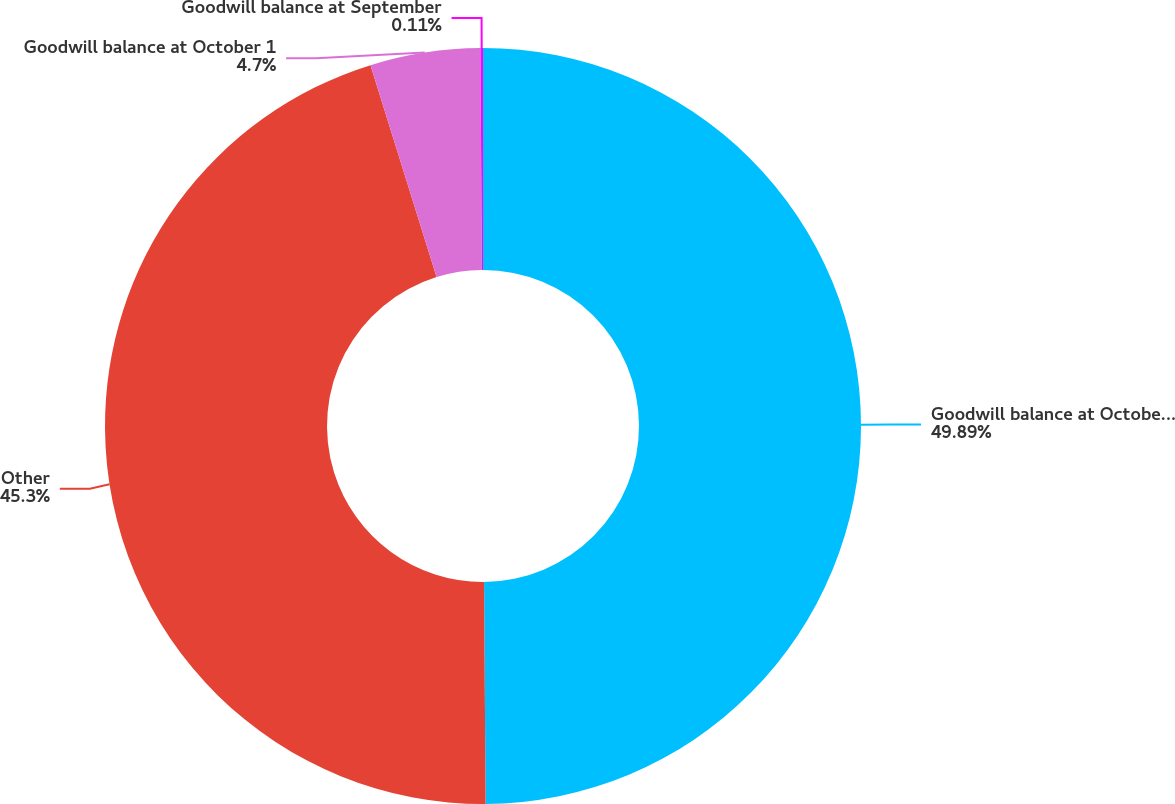<chart> <loc_0><loc_0><loc_500><loc_500><pie_chart><fcel>Goodwill balance at October 2<fcel>Other<fcel>Goodwill balance at October 1<fcel>Goodwill balance at September<nl><fcel>49.89%<fcel>45.3%<fcel>4.7%<fcel>0.11%<nl></chart> 